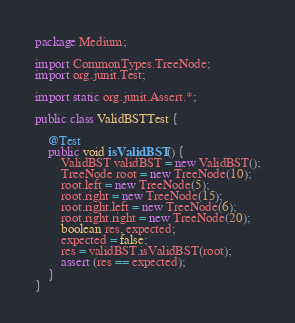<code> <loc_0><loc_0><loc_500><loc_500><_Java_>package Medium;

import CommonTypes.TreeNode;
import org.junit.Test;

import static org.junit.Assert.*;

public class ValidBSTTest {

    @Test
    public void isValidBST() {
        ValidBST validBST = new ValidBST();
        TreeNode root = new TreeNode(10);
        root.left = new TreeNode(5);
        root.right = new TreeNode(15);
        root.right.left = new TreeNode(6);
        root.right.right = new TreeNode(20);
        boolean res, expected;
        expected = false;
        res = validBST.isValidBST(root);
        assert (res == expected);
    }
}</code> 